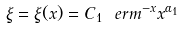<formula> <loc_0><loc_0><loc_500><loc_500>\xi = \xi ( x ) = C _ { 1 } \ e r m ^ { - x } x ^ { \alpha _ { 1 } }</formula> 